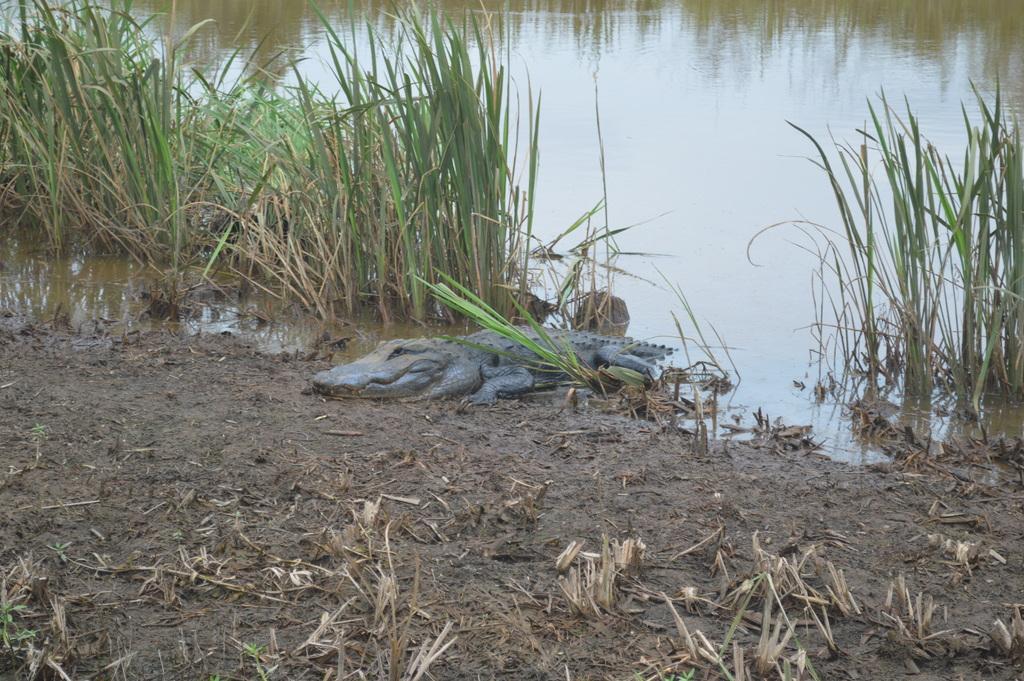Describe this image in one or two sentences. In this image we can see a crocodile on the ground, grass and water. 